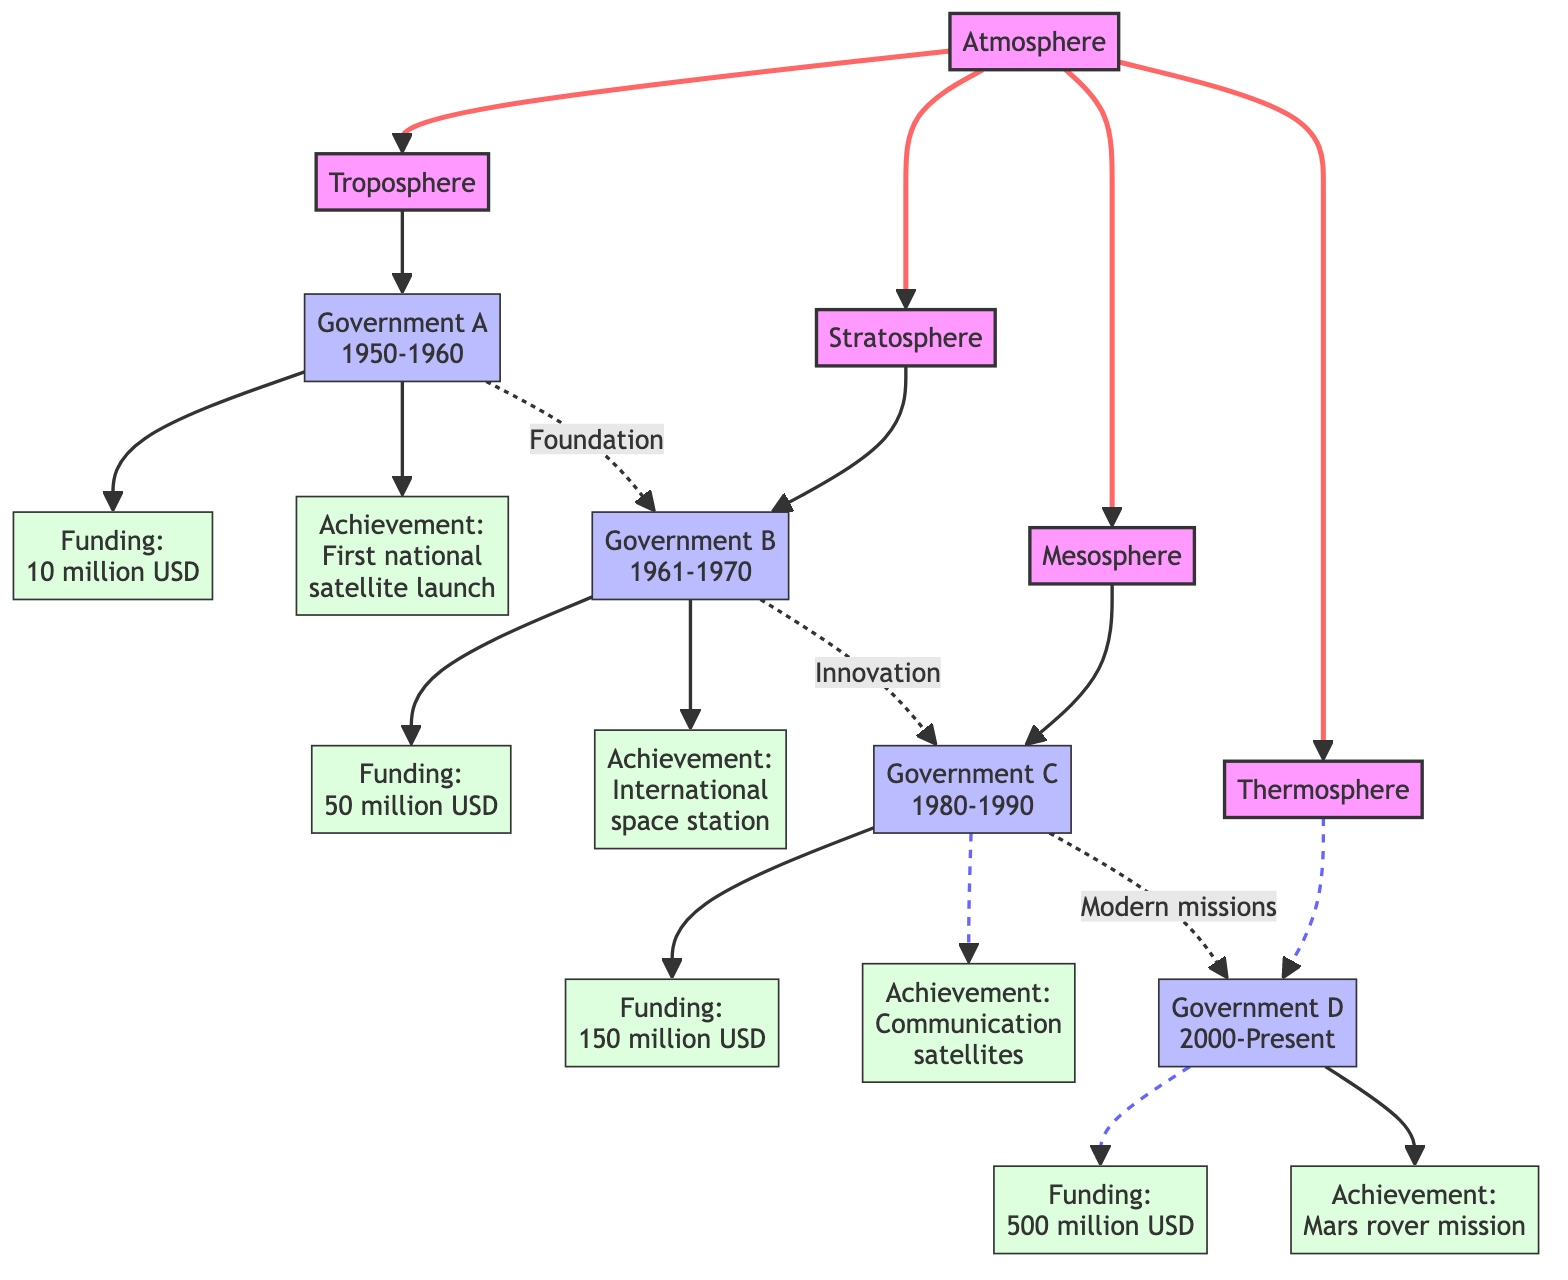What is the achievement of Government A? The diagram states that Government A's achievement is the "First national satellite launch." This is found in the direct line connecting Government A to its contributions.
Answer: First national satellite launch How much funding did Government C provide? The node for Government C shows "Funding: 150 million USD." This is directly indicated next to the Government C node in the diagram.
Answer: 150 million USD Which government had the highest funding contribution? By comparing the funding amounts listed for each government, Government D has the highest funding of "500 million USD." This is indicated at the end of the funding flow in the diagram.
Answer: Government D What is the achievement of Government D? The achievement for Government D is listed as the "Mars rover mission." By following the contributions from Government D, this information becomes clear.
Answer: Mars rover mission How many governments are represented in the diagram? The diagram lists four distinct governments: A, B, C, and D. Each government is shown in its own unique layer, which totals to four nodes in the government layer.
Answer: 4 What foundational influence did Government A have on Government B? The diagram indicates that Government A provided a "Foundation" for Government B. This connection is represented as a dashed line between the two government nodes, indicating a supporting role rather than direct funding or achievement.
Answer: Foundation What major innovation did Government B lead to? The contribution of Government B resulted in an "International space station." This achievement is shown as a direct connection from Government B in the diagram.
Answer: International space station What role did Government C play in the progression to Government D? The diagram states that Government C's contributions led to "Modern missions," which is portrayed as a connecting element between the two government nodes. This indicates that Government C's achievements paved the way for future developments under Government D.
Answer: Modern missions What was the total funding contributed by all governments combined? The total funding can be calculated by adding the funding amounts of each government: 10 million USD + 50 million USD + 150 million USD + 500 million USD = 710 million USD. This requires the summation of all the individual funding nodes listed in the diagram.
Answer: 710 million USD 